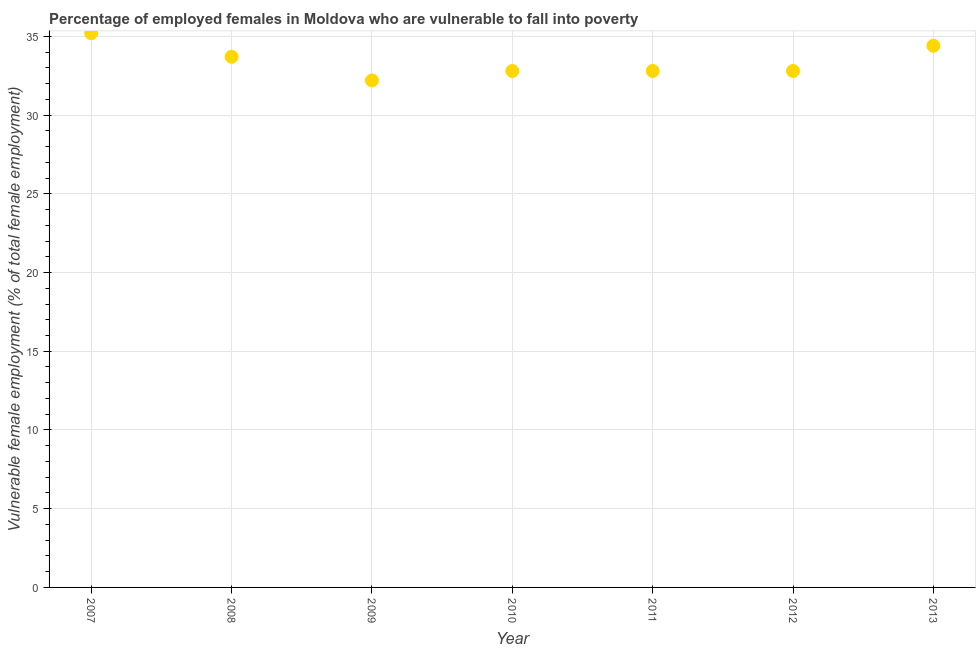What is the percentage of employed females who are vulnerable to fall into poverty in 2007?
Provide a short and direct response. 35.2. Across all years, what is the maximum percentage of employed females who are vulnerable to fall into poverty?
Keep it short and to the point. 35.2. Across all years, what is the minimum percentage of employed females who are vulnerable to fall into poverty?
Provide a succinct answer. 32.2. What is the sum of the percentage of employed females who are vulnerable to fall into poverty?
Ensure brevity in your answer.  233.9. What is the difference between the percentage of employed females who are vulnerable to fall into poverty in 2009 and 2011?
Offer a very short reply. -0.6. What is the average percentage of employed females who are vulnerable to fall into poverty per year?
Provide a short and direct response. 33.41. What is the median percentage of employed females who are vulnerable to fall into poverty?
Ensure brevity in your answer.  32.8. In how many years, is the percentage of employed females who are vulnerable to fall into poverty greater than 24 %?
Offer a terse response. 7. Do a majority of the years between 2009 and 2008 (inclusive) have percentage of employed females who are vulnerable to fall into poverty greater than 26 %?
Your answer should be compact. No. What is the ratio of the percentage of employed females who are vulnerable to fall into poverty in 2007 to that in 2012?
Your answer should be very brief. 1.07. Is the percentage of employed females who are vulnerable to fall into poverty in 2008 less than that in 2010?
Make the answer very short. No. Is the difference between the percentage of employed females who are vulnerable to fall into poverty in 2009 and 2010 greater than the difference between any two years?
Your answer should be compact. No. What is the difference between the highest and the second highest percentage of employed females who are vulnerable to fall into poverty?
Your response must be concise. 0.8. What is the difference between the highest and the lowest percentage of employed females who are vulnerable to fall into poverty?
Your answer should be very brief. 3. Does the percentage of employed females who are vulnerable to fall into poverty monotonically increase over the years?
Offer a terse response. No. What is the difference between two consecutive major ticks on the Y-axis?
Offer a terse response. 5. Does the graph contain grids?
Your answer should be very brief. Yes. What is the title of the graph?
Your response must be concise. Percentage of employed females in Moldova who are vulnerable to fall into poverty. What is the label or title of the Y-axis?
Your response must be concise. Vulnerable female employment (% of total female employment). What is the Vulnerable female employment (% of total female employment) in 2007?
Your answer should be very brief. 35.2. What is the Vulnerable female employment (% of total female employment) in 2008?
Offer a terse response. 33.7. What is the Vulnerable female employment (% of total female employment) in 2009?
Ensure brevity in your answer.  32.2. What is the Vulnerable female employment (% of total female employment) in 2010?
Your response must be concise. 32.8. What is the Vulnerable female employment (% of total female employment) in 2011?
Offer a very short reply. 32.8. What is the Vulnerable female employment (% of total female employment) in 2012?
Offer a very short reply. 32.8. What is the Vulnerable female employment (% of total female employment) in 2013?
Make the answer very short. 34.4. What is the difference between the Vulnerable female employment (% of total female employment) in 2007 and 2012?
Provide a short and direct response. 2.4. What is the difference between the Vulnerable female employment (% of total female employment) in 2008 and 2011?
Offer a terse response. 0.9. What is the difference between the Vulnerable female employment (% of total female employment) in 2008 and 2013?
Keep it short and to the point. -0.7. What is the difference between the Vulnerable female employment (% of total female employment) in 2011 and 2013?
Your response must be concise. -1.6. What is the ratio of the Vulnerable female employment (% of total female employment) in 2007 to that in 2008?
Your response must be concise. 1.04. What is the ratio of the Vulnerable female employment (% of total female employment) in 2007 to that in 2009?
Offer a very short reply. 1.09. What is the ratio of the Vulnerable female employment (% of total female employment) in 2007 to that in 2010?
Offer a terse response. 1.07. What is the ratio of the Vulnerable female employment (% of total female employment) in 2007 to that in 2011?
Give a very brief answer. 1.07. What is the ratio of the Vulnerable female employment (% of total female employment) in 2007 to that in 2012?
Give a very brief answer. 1.07. What is the ratio of the Vulnerable female employment (% of total female employment) in 2008 to that in 2009?
Keep it short and to the point. 1.05. What is the ratio of the Vulnerable female employment (% of total female employment) in 2008 to that in 2012?
Keep it short and to the point. 1.03. What is the ratio of the Vulnerable female employment (% of total female employment) in 2009 to that in 2010?
Provide a succinct answer. 0.98. What is the ratio of the Vulnerable female employment (% of total female employment) in 2009 to that in 2012?
Give a very brief answer. 0.98. What is the ratio of the Vulnerable female employment (% of total female employment) in 2009 to that in 2013?
Offer a terse response. 0.94. What is the ratio of the Vulnerable female employment (% of total female employment) in 2010 to that in 2011?
Your response must be concise. 1. What is the ratio of the Vulnerable female employment (% of total female employment) in 2010 to that in 2012?
Your answer should be very brief. 1. What is the ratio of the Vulnerable female employment (% of total female employment) in 2010 to that in 2013?
Your response must be concise. 0.95. What is the ratio of the Vulnerable female employment (% of total female employment) in 2011 to that in 2012?
Your answer should be very brief. 1. What is the ratio of the Vulnerable female employment (% of total female employment) in 2011 to that in 2013?
Make the answer very short. 0.95. What is the ratio of the Vulnerable female employment (% of total female employment) in 2012 to that in 2013?
Provide a short and direct response. 0.95. 